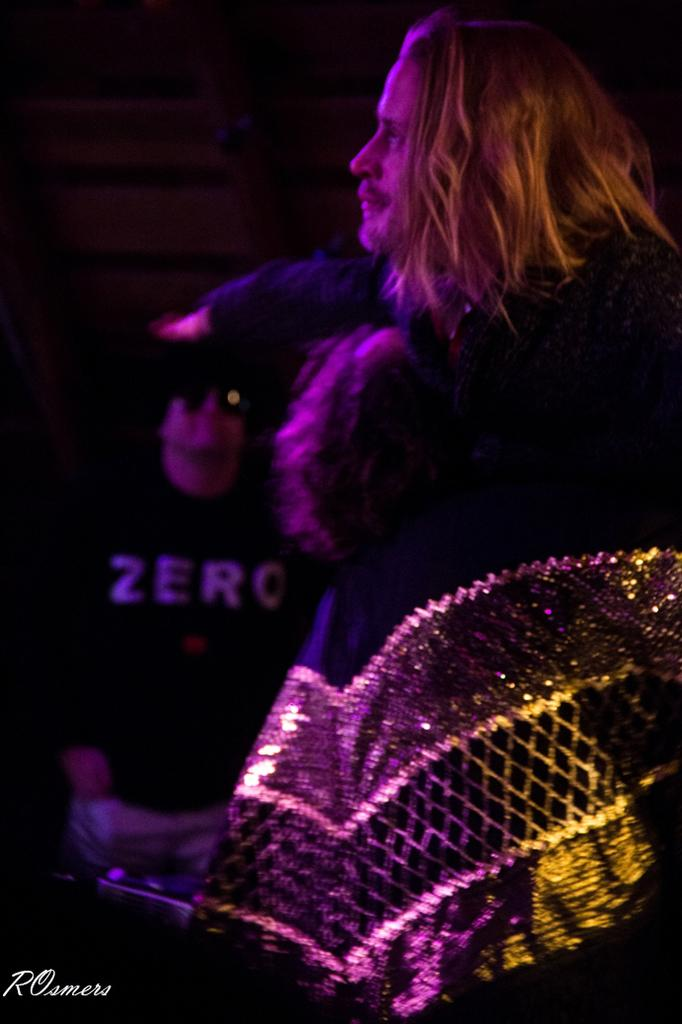What is the main subject of the image? There is a person in the image. What is the person doing in the image? The person is standing. What is the person wearing in the image? The person is wearing a black dress. What type of pet can be seen in the person's arms in the image? There is no pet visible in the image; the person is not holding anything. What type of prose is the person reciting in the image? There is no indication in the image that the person is reciting any prose. 